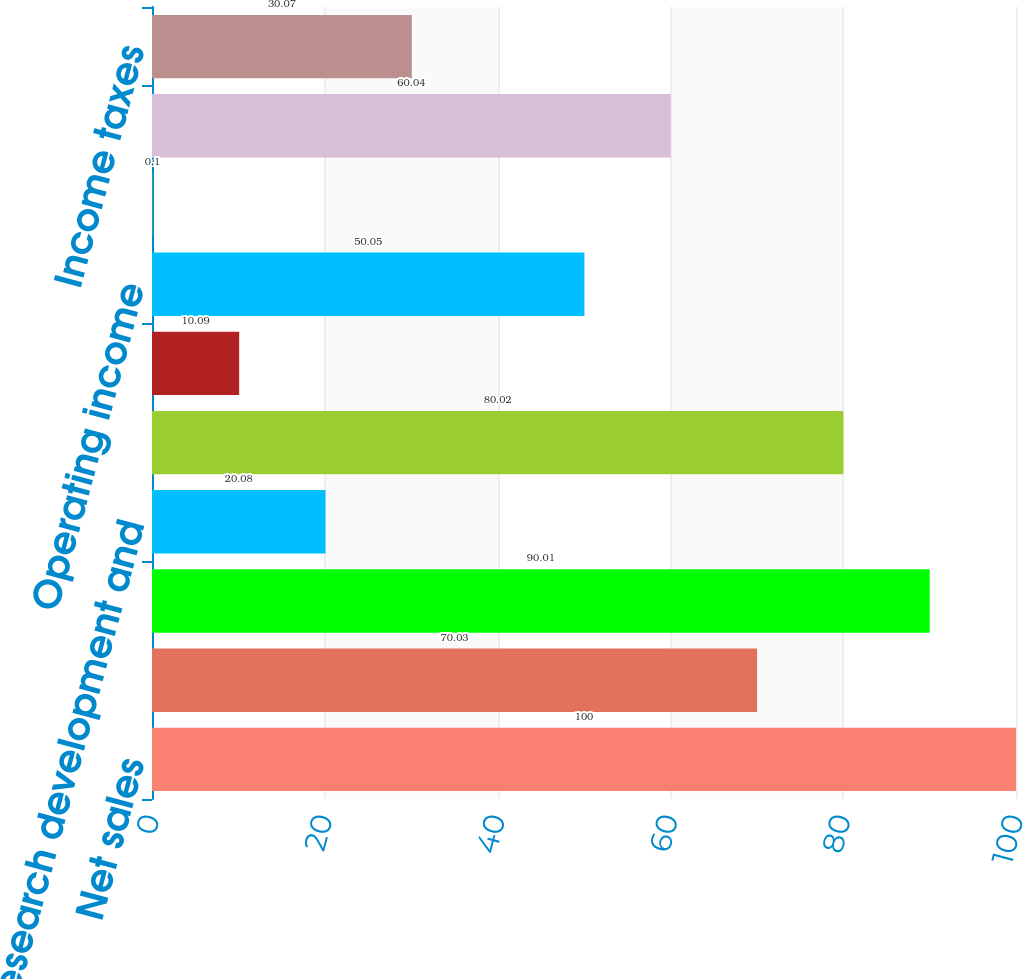<chart> <loc_0><loc_0><loc_500><loc_500><bar_chart><fcel>Net sales<fcel>Cost of sales<fcel>Gross profi t<fcel>Research development and<fcel>Selling general and<fcel>Intangibles amortization<fcel>Operating income<fcel>Other income (expense)<fcel>Earnings from continuing<fcel>Income taxes<nl><fcel>100<fcel>70.03<fcel>90.01<fcel>20.08<fcel>80.02<fcel>10.09<fcel>50.05<fcel>0.1<fcel>60.04<fcel>30.07<nl></chart> 